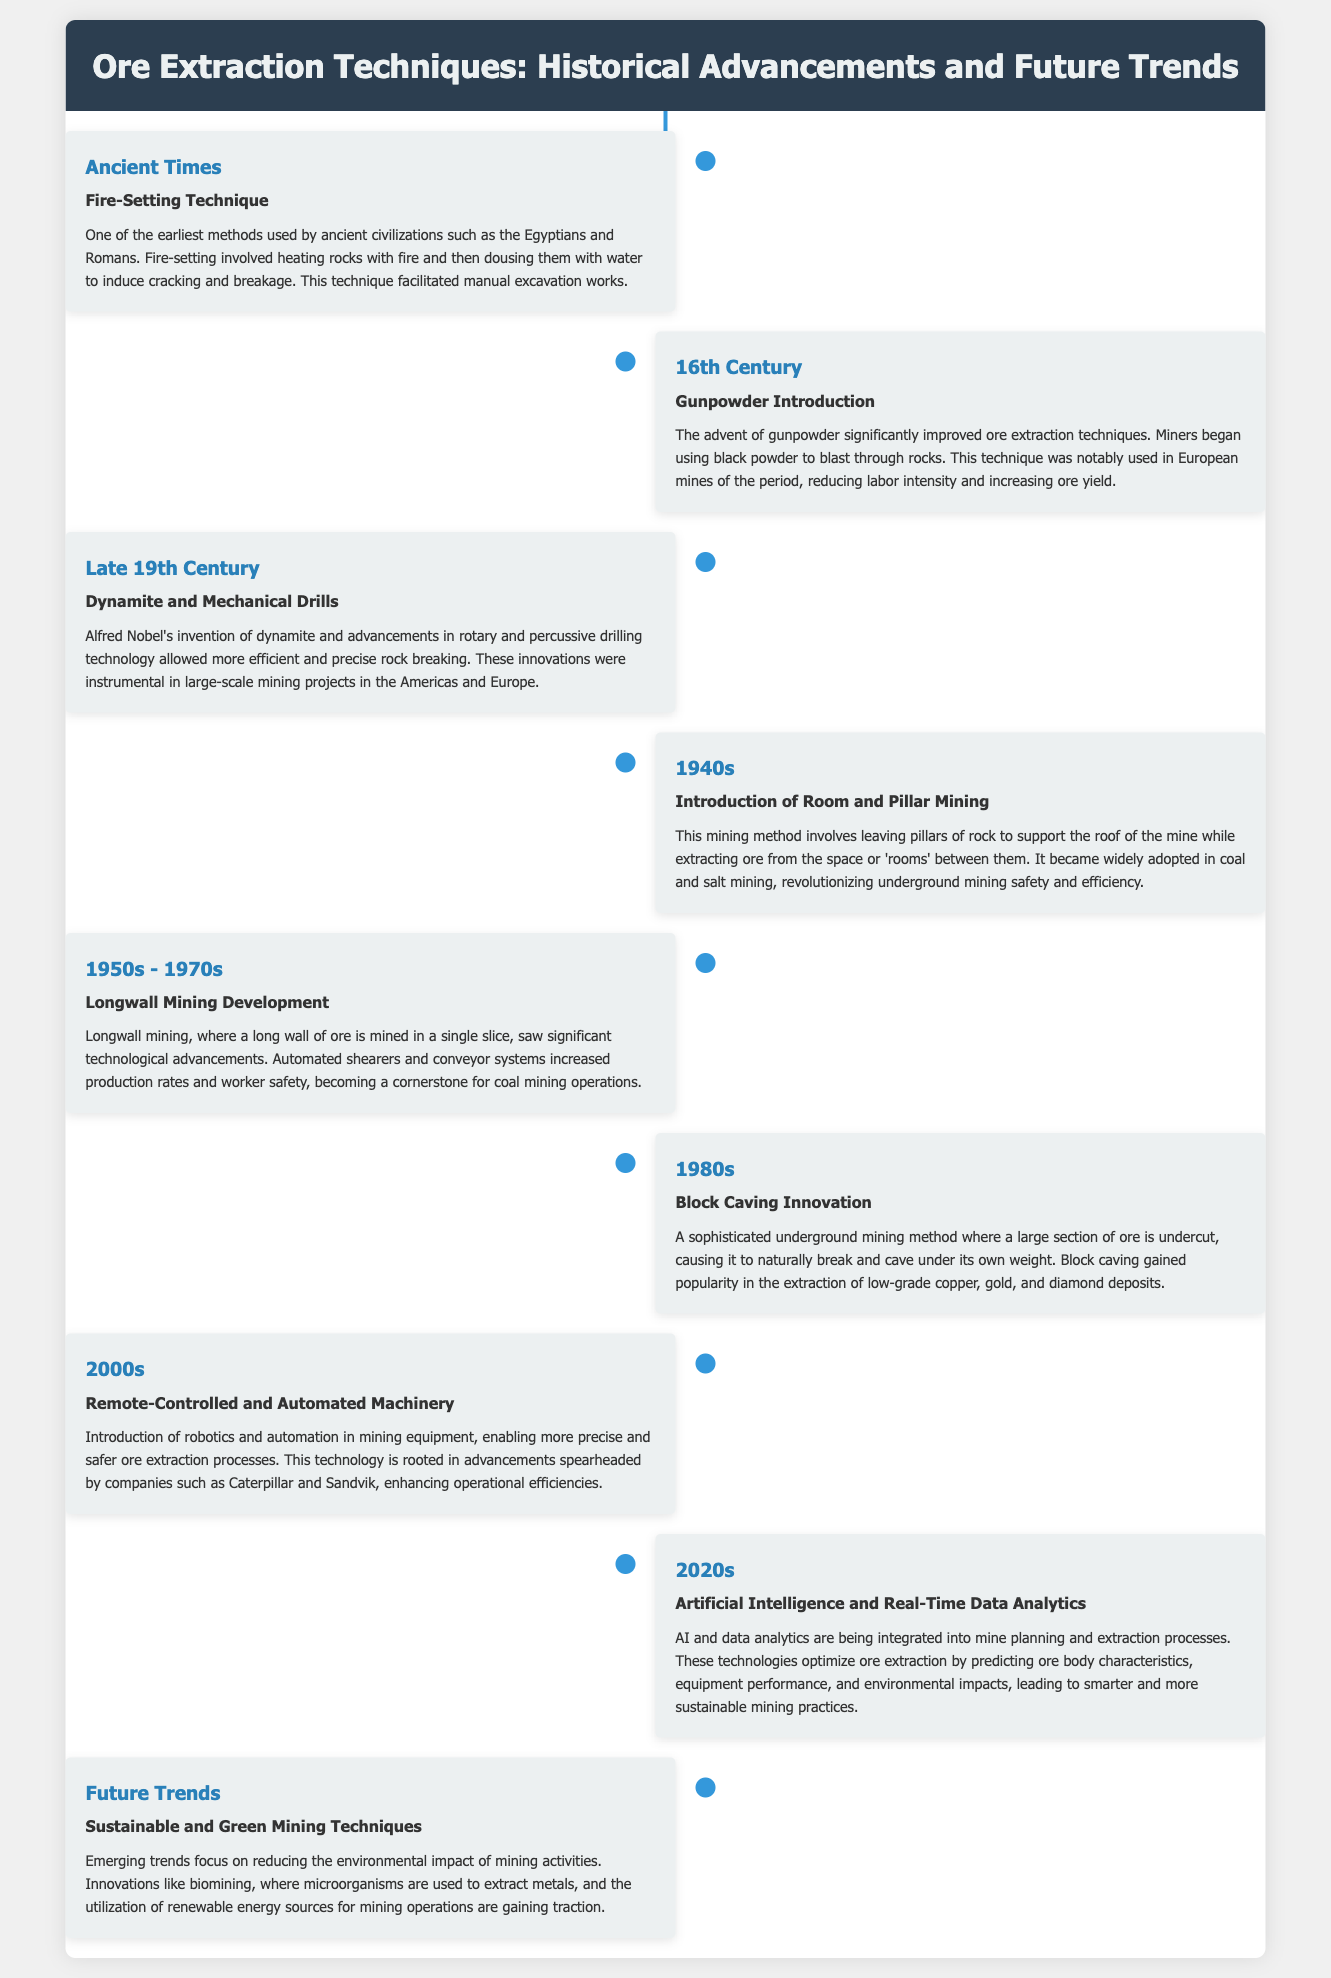What technique was used by ancient civilizations for ore extraction? The document mentions that ancient civilizations such as the Egyptians and Romans used the fire-setting technique for ore extraction.
Answer: Fire-Setting Technique In which century did the introduction of gunpowder significantly improve ore extraction? According to the timeline, the advent of gunpowder occurred in the 16th century, enhancing ore extraction techniques.
Answer: 16th Century Who invented dynamite, leading to advancements in ore extraction? The document states that Alfred Nobel invented dynamite, which allowed for more efficient rock breaking.
Answer: Alfred Nobel What mining method was introduced in the 1940s? The timeline indicates that the room and pillar mining method was introduced during the 1940s.
Answer: Room and Pillar Mining Which mining technique developed in the 1950s to 1970s involves extracting coal in a single slice? The description for the period highlights that longwall mining involves the extraction of coal in a singular slice.
Answer: Longwall Mining What is one of the future trends focused on in ore extraction techniques? The document mentions that sustainable and green mining techniques are becoming central to future trends in the industry.
Answer: Sustainable and Green Mining Techniques What type of technology was introduced in the 2000s for ore extraction? The timeline points out that remote-controlled and automated machinery was introduced to enhance ore extraction processes.
Answer: Remote-Controlled and Automated Machinery Which decade saw significant technological advancements for longwall mining? According to the timeline, the technological advancements for longwall mining occurred during the 1950s to 1970s.
Answer: 1950s - 1970s What is the key focus of the 2020s developments in mining? The document notes that the integration of artificial intelligence and real-time data analytics in mining processes is a key focus in the 2020s.
Answer: Artificial Intelligence and Real-Time Data Analytics 